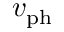<formula> <loc_0><loc_0><loc_500><loc_500>v _ { p h }</formula> 